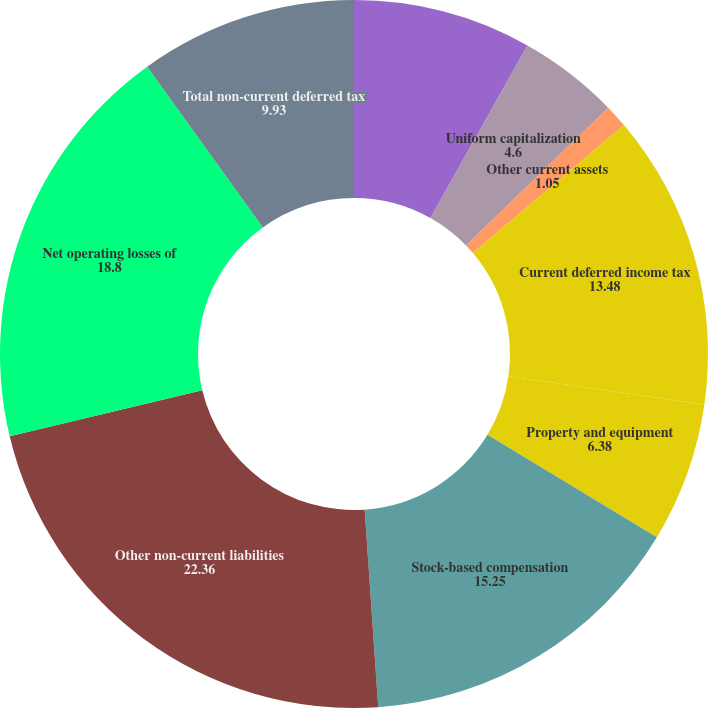Convert chart to OTSL. <chart><loc_0><loc_0><loc_500><loc_500><pie_chart><fcel>valuation allowances<fcel>Uniform capitalization<fcel>Other current assets<fcel>Current deferred income tax<fcel>Property and equipment<fcel>Stock-based compensation<fcel>Other non-current liabilities<fcel>Net operating losses of<fcel>Total non-current deferred tax<nl><fcel>8.15%<fcel>4.6%<fcel>1.05%<fcel>13.48%<fcel>6.38%<fcel>15.25%<fcel>22.36%<fcel>18.8%<fcel>9.93%<nl></chart> 